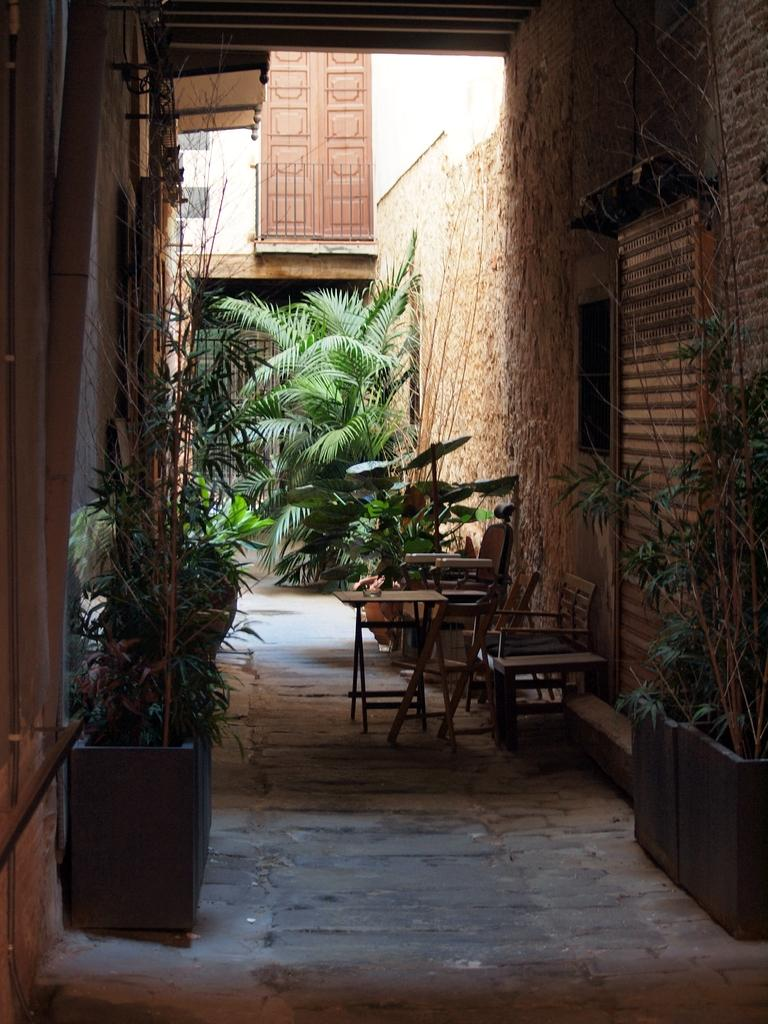What type of vegetation can be seen on both sides of the image? There are plants on both sides of the image. What is located on the right side of the image? There is a wall on the right side of the image. What can be seen in the background of the image? There are chairs in the background of the image. What feature is present in the image that allows access to another area? There is a door in the image. What type of structure is visible in the image? There is a wall visible in the image. What type of cracker is being used as a boundary in the image? There is no cracker present in the image, nor is there any indication of a boundary. What type of pest can be seen crawling on the wall in the image? There are no pests visible in the image; only plants, a wall, chairs, and a door are present. 